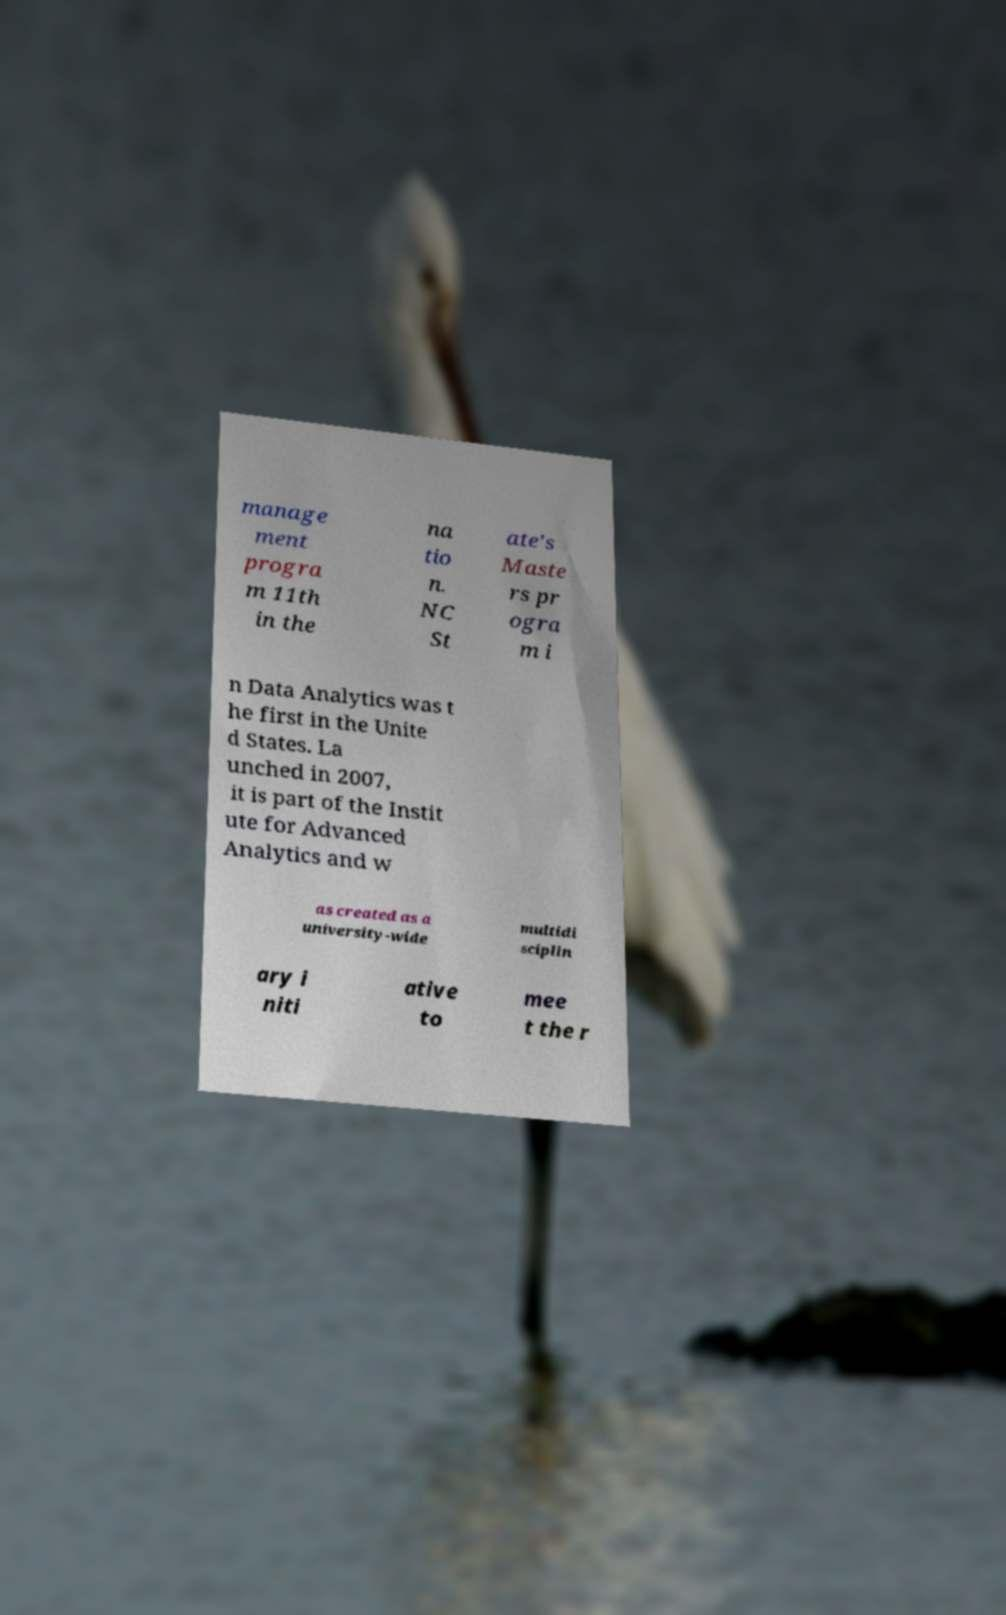There's text embedded in this image that I need extracted. Can you transcribe it verbatim? manage ment progra m 11th in the na tio n. NC St ate's Maste rs pr ogra m i n Data Analytics was t he first in the Unite d States. La unched in 2007, it is part of the Instit ute for Advanced Analytics and w as created as a university-wide multidi sciplin ary i niti ative to mee t the r 